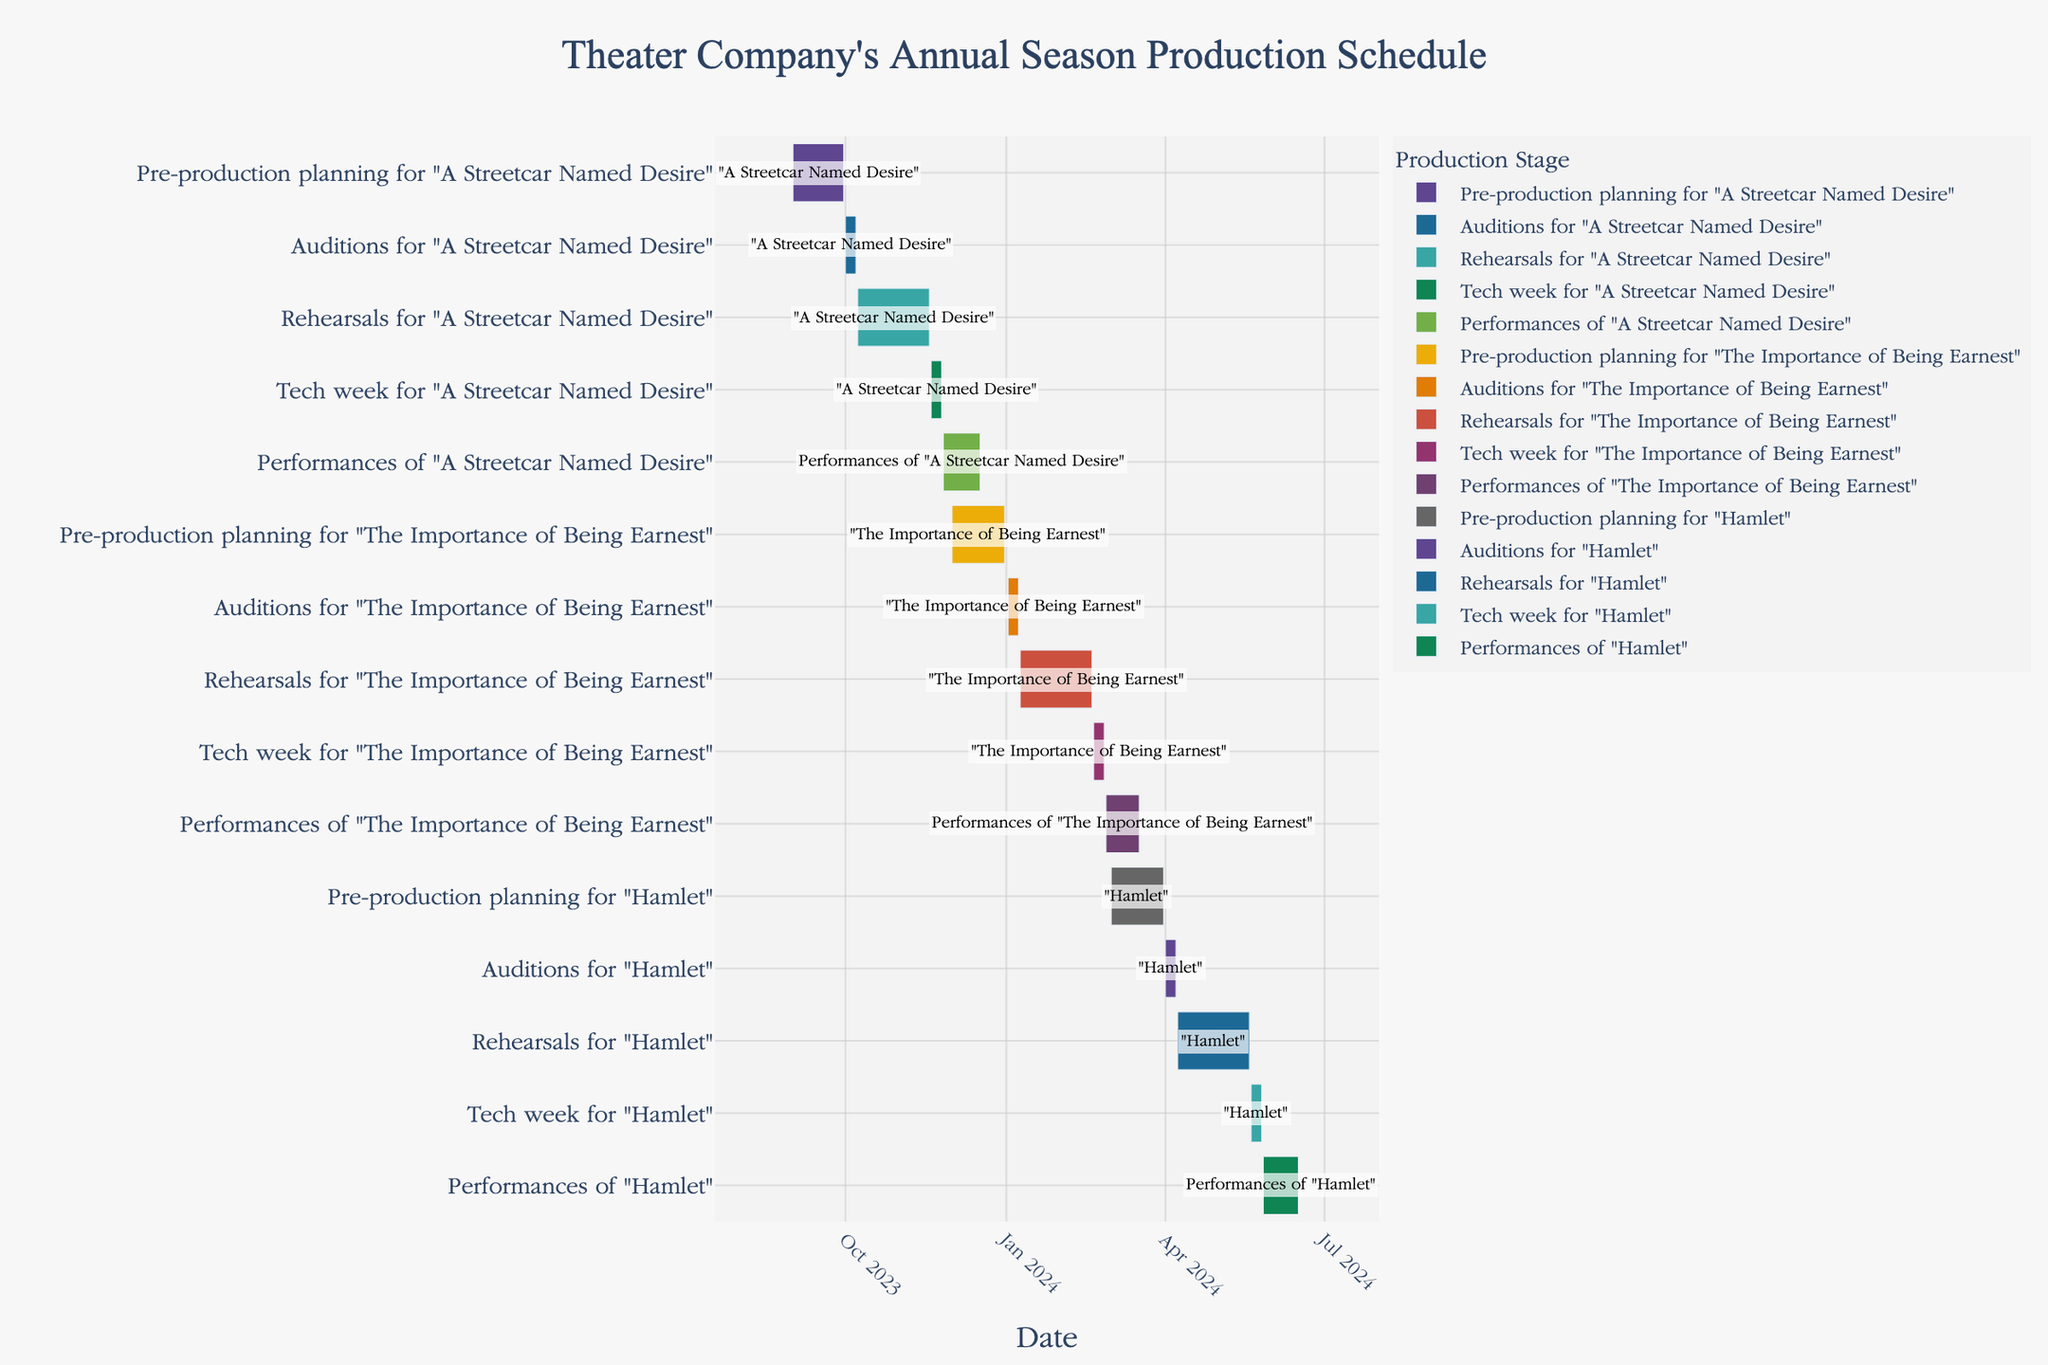What is the duration of the pre-production planning for "A Streetcar Named Desire"? To determine the duration, find the start and end dates for the pre-production planning task for "A Streetcar Named Desire". The start date is 2023-09-01 and the end date is 2023-09-30. Subtract the start date from the end date and add 1 to include both dates, which gives (30 - 1 + 1) days.
Answer: 30 days Which show has the longest rehearsal period? To find this, check the start and end dates for the rehearsal periods of all shows. "A Streetcar Named Desire" has rehearsals from 2023-10-08 to 2023-11-18 (42 days), "The Importance of Being Earnest" from 2024-01-09 to 2024-02-19 (42 days), and "Hamlet" from 2024-04-08 to 2024-05-19 (42 days). All shows have the same duration of rehearsals.
Answer: All shows have the same duration of rehearsals When do the performances of "Hamlet" start? To find the start date of the performances of "Hamlet", look for the task “Performances of Hamlet” on the y-axis, and read the corresponding start date on the x-axis. The performances start on 2024-05-27.
Answer: 2024-05-27 How many total days are allocated to performances across all three shows? To determine this, add up the duration of the performance periods for each show. "A Streetcar Named Desire" performances last from 2023-11-26 to 2023-12-17 (22 days), "The Importance of Being Earnest" from 2024-02-27 to 2024-03-17 (20 days), and "Hamlet" from 2024-05-27 to 2024-06-16 (21 days). Summing these durations gives 22 + 20 + 21 = 63 days.
Answer: 63 days Which stage comes immediately after the auditions for "The Importance of Being Earnest"? Look for the auditions task for "The Importance of Being Earnest" and check the next stage on the timeline that starts after 2024-01-08. The next stage is rehearsals, which start on 2024-01-09.
Answer: Rehearsals Compare the duration of tech week for all shows. Which one is the shortest? Check the tech week durations for each show: "A Streetcar Named Desire" from 2023-11-19 to 2023-11-25 (7 days), "The Importance of Being Earnest" from 2024-02-20 to 2024-02-26 (7 days) and "Hamlet" from 2024-05-20 to 2024-05-26 (7 days). All tech weeks have the same duration.
Answer: All are equal What is the gap between the end of "A Streetcar Named Desire" performances and the start of "The Importance of Being Earnest" pre-production planning? Find the end date of "A Streetcar Named Desire" performances (2023-12-17) and the start date of "The Importance of Being Earnest" pre-production planning (2023-12-01). Calculate the difference: 2023-12-01 is before 2023-12-17, so there is an overlap of 17 days in their timelines.
Answer: -17 days overlap What tasks are planned in January 2024? Check the tasks that overlap with January 2024 on the timeline. "Pre-production planning for 'The Importance of Being Earnest'" runs until 2023-12-31 overlapping into January 2024, auditions begin on 2024-01-02, and rehearsals start on 2024-01-09.
Answer: Pre-production planning, Auditions, Rehearsals for "The Importance of Being Earnest" When does the tech week for "A Streetcar Named Desire" end? Find the task "Tech week for 'A Streetcar Named Desire'" on the y-axis and read the end date on the x-axis. It ends on 2023-11-25.
Answer: 2023-11-25 